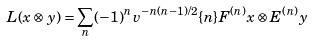Convert formula to latex. <formula><loc_0><loc_0><loc_500><loc_500>L ( x \otimes y ) = \sum _ { n } ( - 1 ) ^ { n } v ^ { - n ( n - 1 ) / 2 } \{ n \} F ^ { ( n ) } x \otimes E ^ { ( n ) } y</formula> 